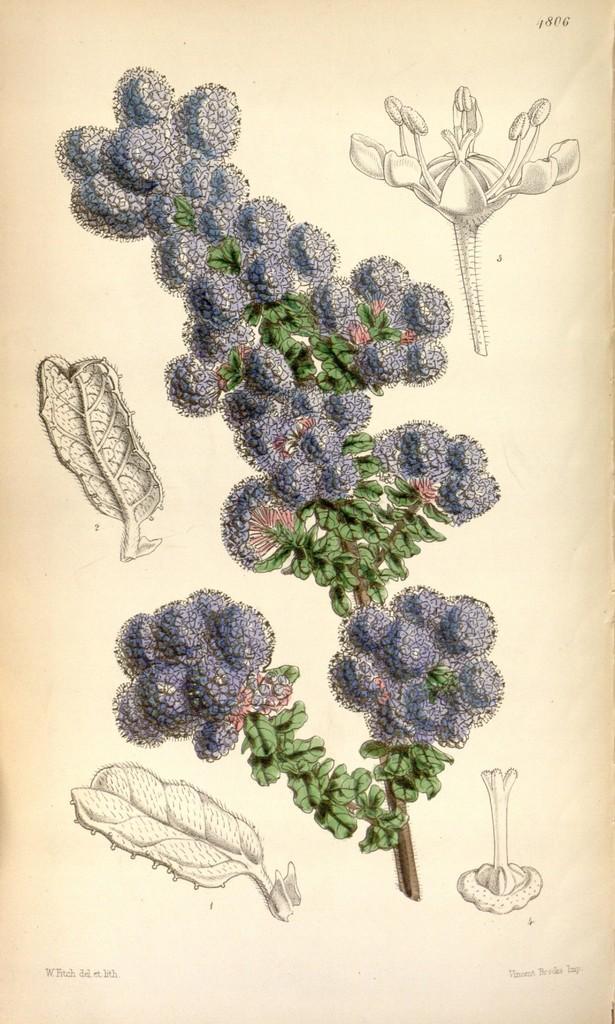In one or two sentences, can you explain what this image depicts? In this image we can see some drawings and text on a paper. 